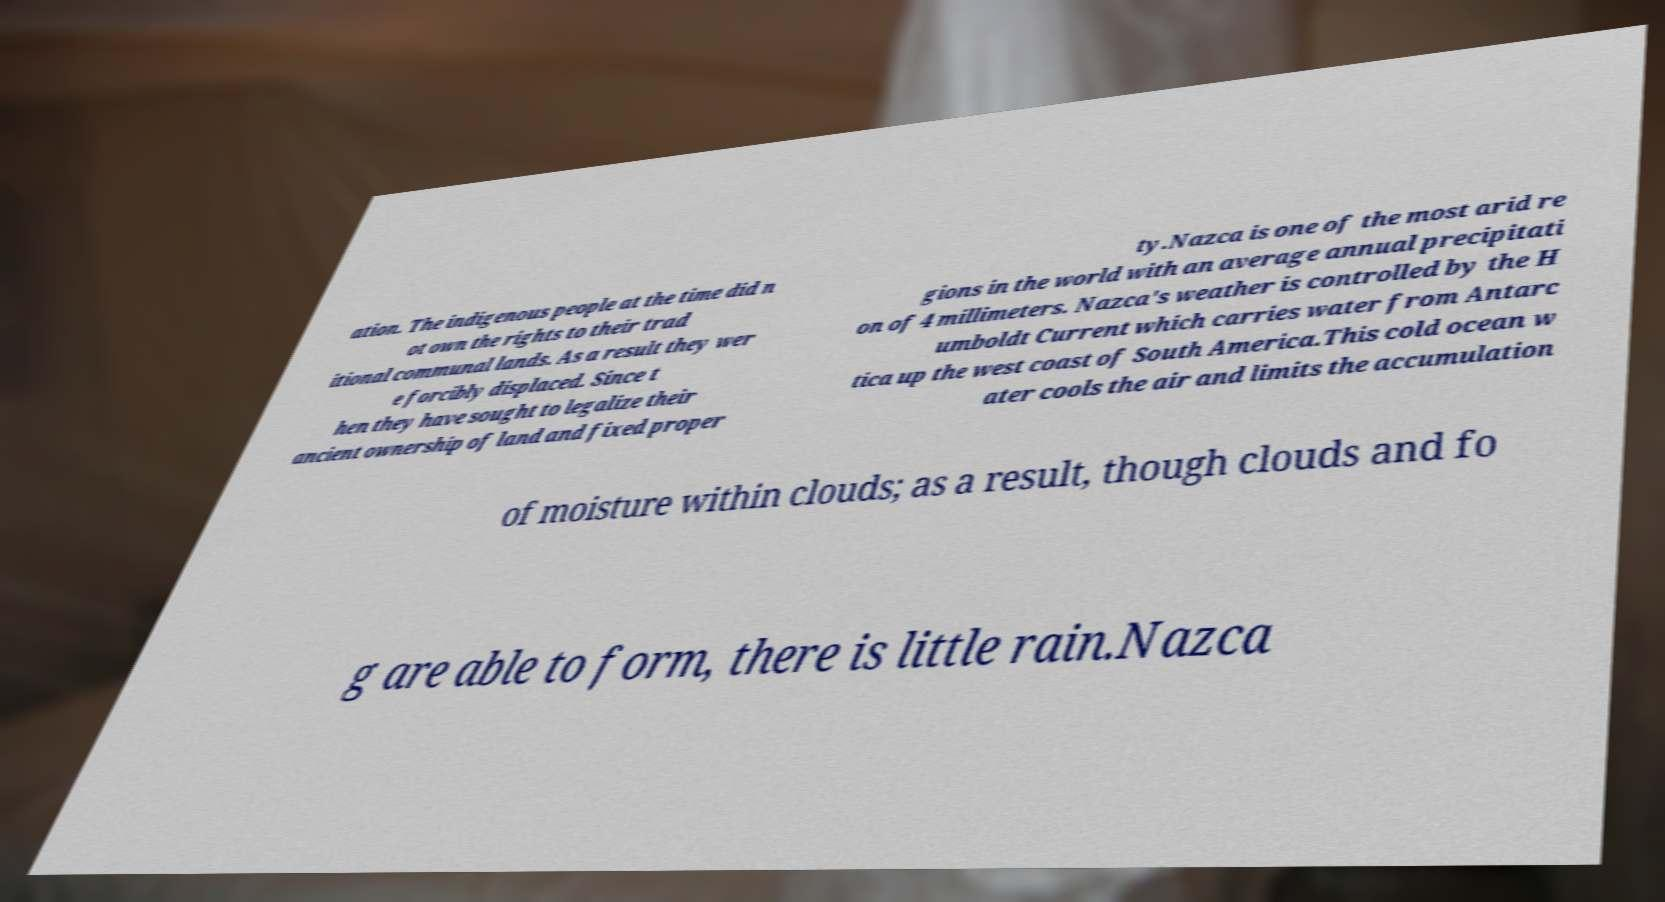Could you extract and type out the text from this image? ation. The indigenous people at the time did n ot own the rights to their trad itional communal lands. As a result they wer e forcibly displaced. Since t hen they have sought to legalize their ancient ownership of land and fixed proper ty.Nazca is one of the most arid re gions in the world with an average annual precipitati on of 4 millimeters. Nazca's weather is controlled by the H umboldt Current which carries water from Antarc tica up the west coast of South America.This cold ocean w ater cools the air and limits the accumulation of moisture within clouds; as a result, though clouds and fo g are able to form, there is little rain.Nazca 